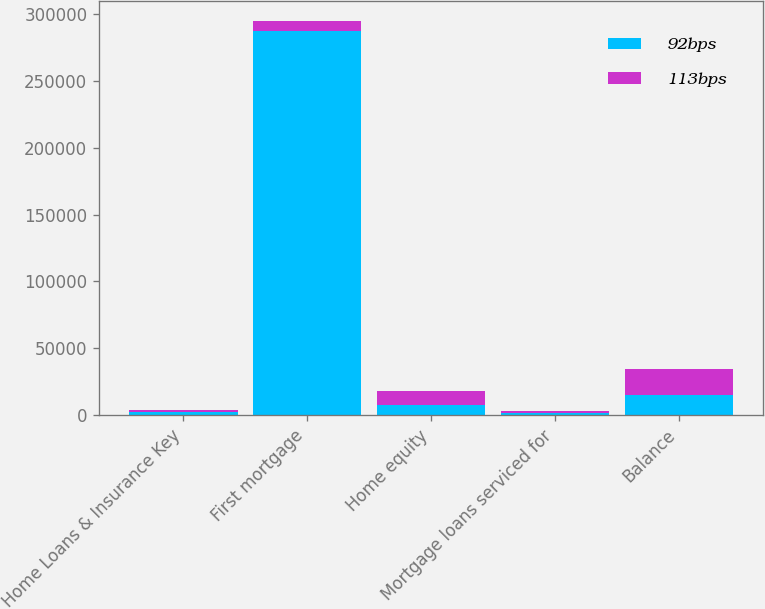Convert chart to OTSL. <chart><loc_0><loc_0><loc_500><loc_500><stacked_bar_chart><ecel><fcel>Home Loans & Insurance Key<fcel>First mortgage<fcel>Home equity<fcel>Mortgage loans serviced for<fcel>Balance<nl><fcel>92bps<fcel>2010<fcel>287236<fcel>7626<fcel>1628<fcel>14900<nl><fcel>113bps<fcel>2009<fcel>7626<fcel>10488<fcel>1716<fcel>19465<nl></chart> 